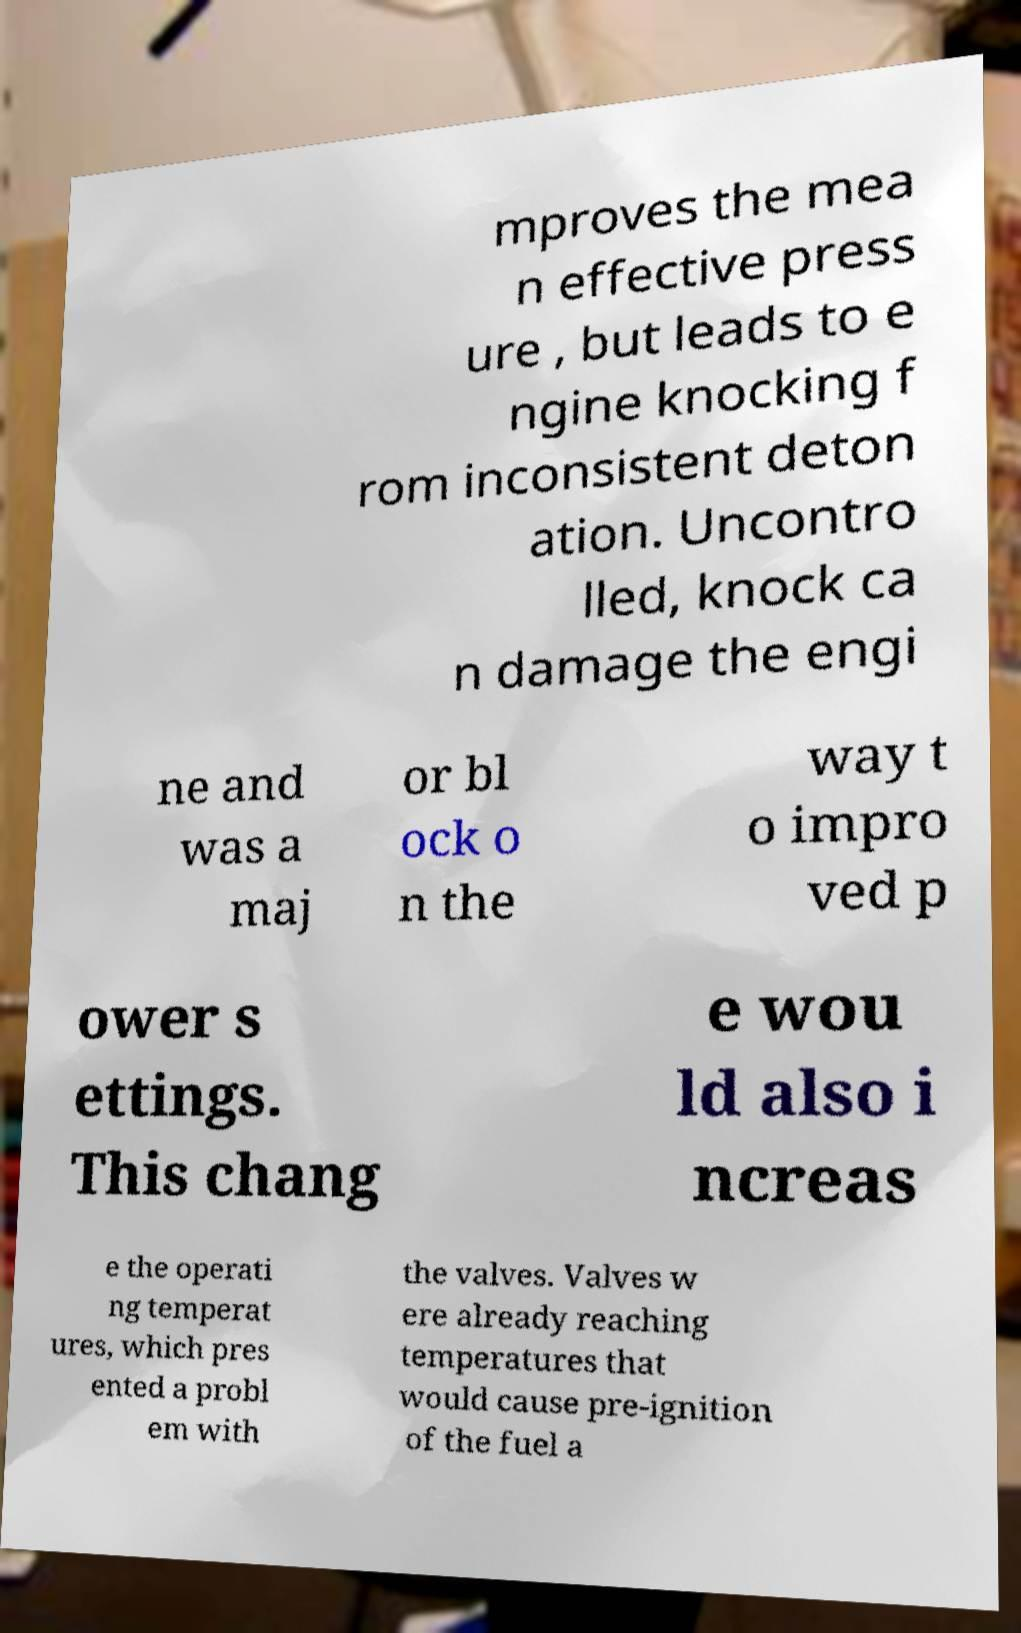I need the written content from this picture converted into text. Can you do that? mproves the mea n effective press ure , but leads to e ngine knocking f rom inconsistent deton ation. Uncontro lled, knock ca n damage the engi ne and was a maj or bl ock o n the way t o impro ved p ower s ettings. This chang e wou ld also i ncreas e the operati ng temperat ures, which pres ented a probl em with the valves. Valves w ere already reaching temperatures that would cause pre-ignition of the fuel a 